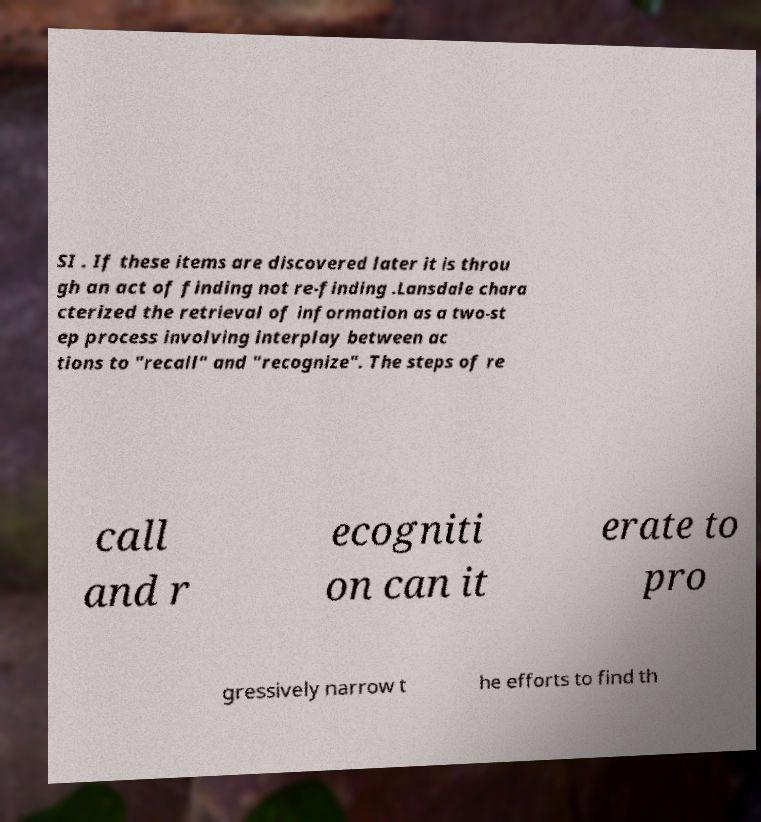I need the written content from this picture converted into text. Can you do that? SI . If these items are discovered later it is throu gh an act of finding not re-finding .Lansdale chara cterized the retrieval of information as a two-st ep process involving interplay between ac tions to "recall" and "recognize". The steps of re call and r ecogniti on can it erate to pro gressively narrow t he efforts to find th 